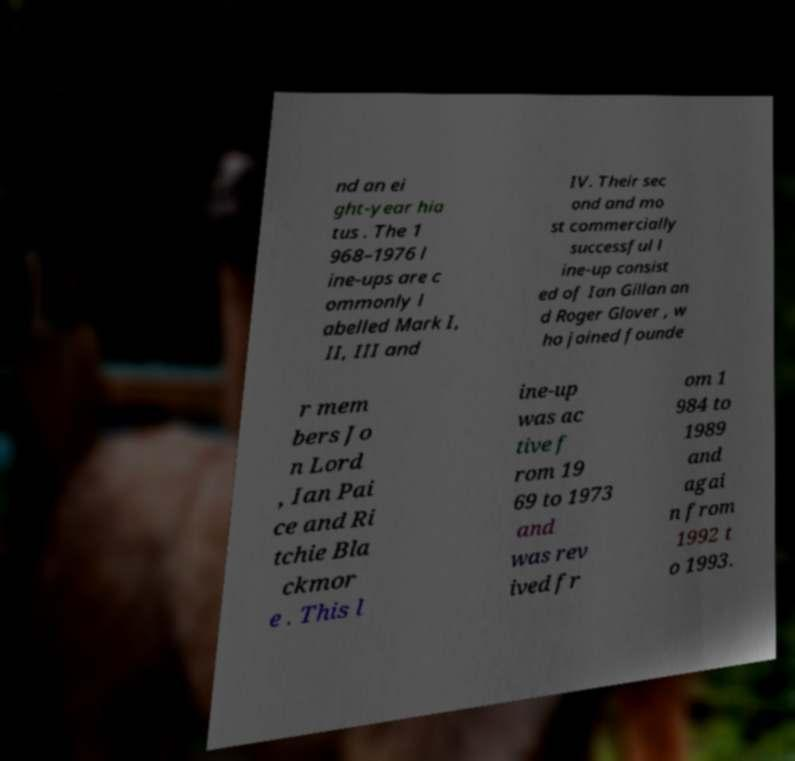There's text embedded in this image that I need extracted. Can you transcribe it verbatim? nd an ei ght-year hia tus . The 1 968–1976 l ine-ups are c ommonly l abelled Mark I, II, III and IV. Their sec ond and mo st commercially successful l ine-up consist ed of Ian Gillan an d Roger Glover , w ho joined founde r mem bers Jo n Lord , Ian Pai ce and Ri tchie Bla ckmor e . This l ine-up was ac tive f rom 19 69 to 1973 and was rev ived fr om 1 984 to 1989 and agai n from 1992 t o 1993. 